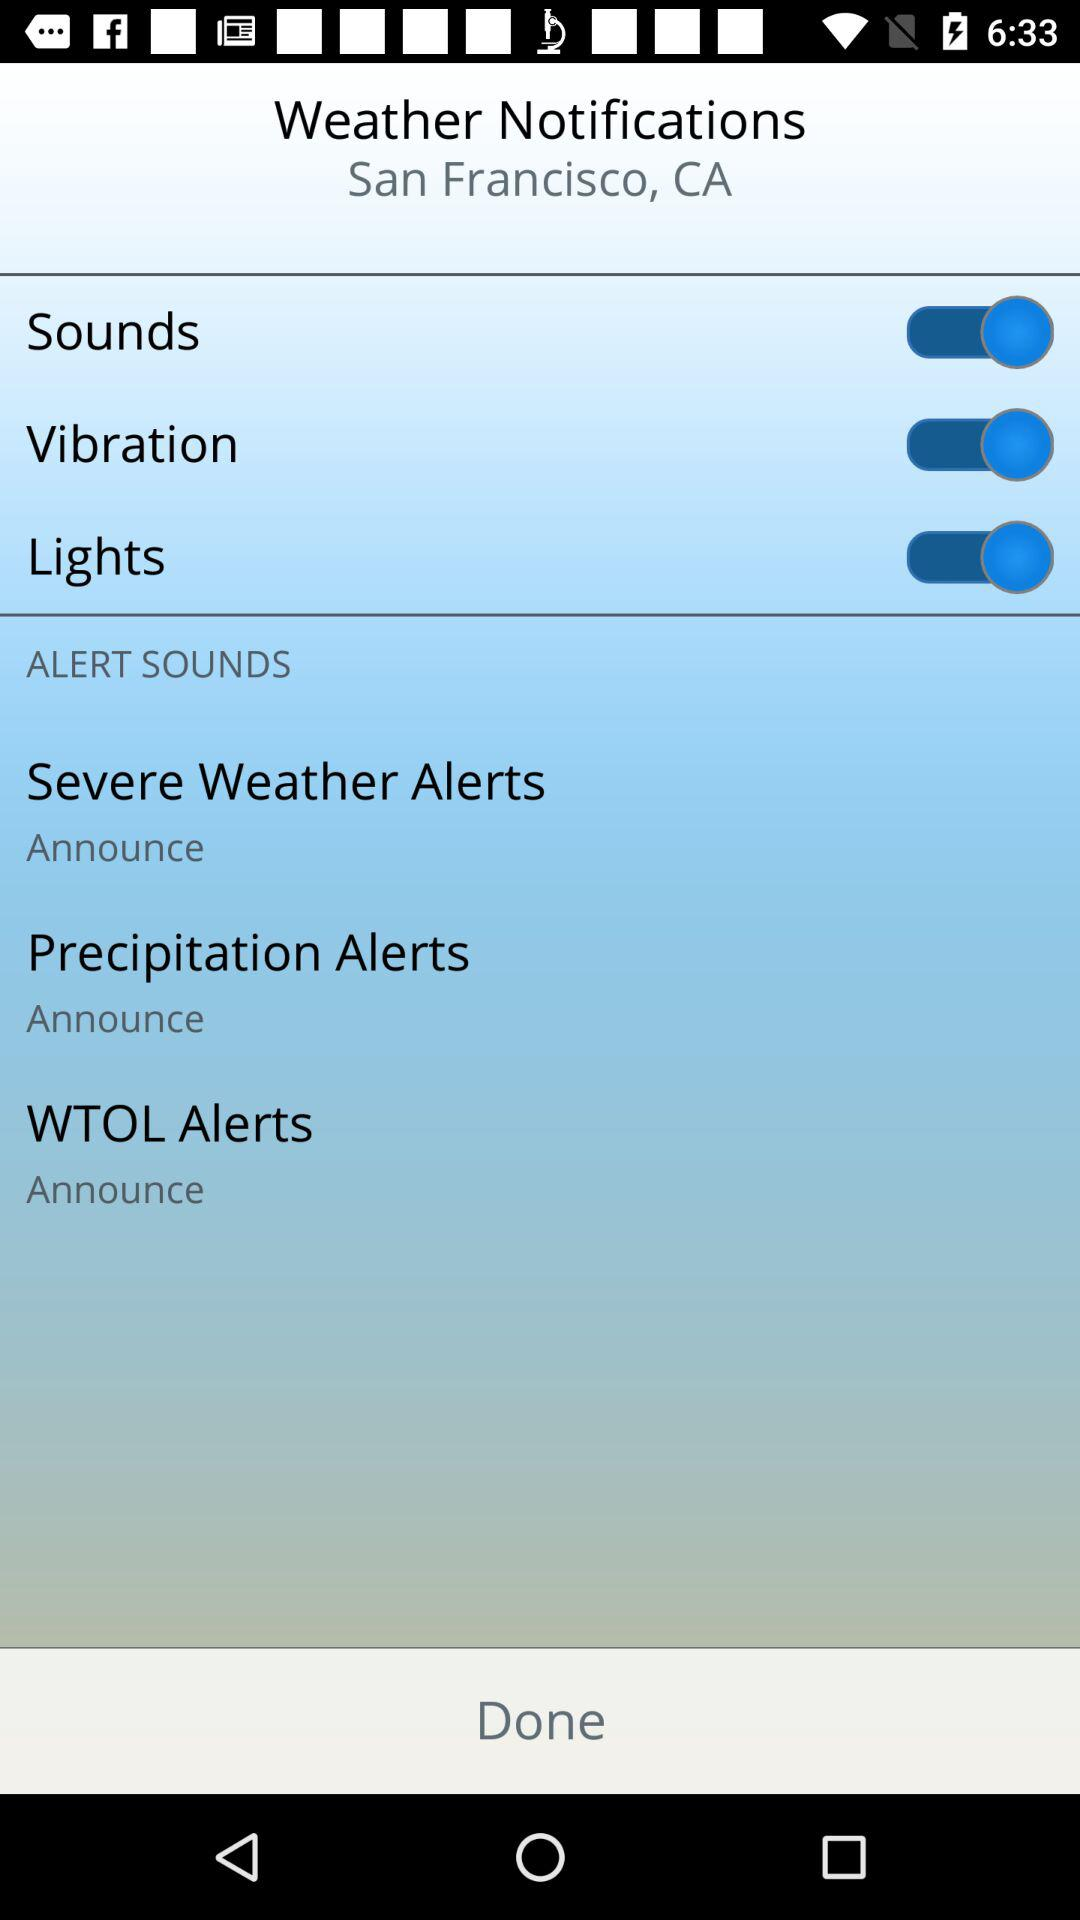What is the status of "Sounds"? The status is "on". 